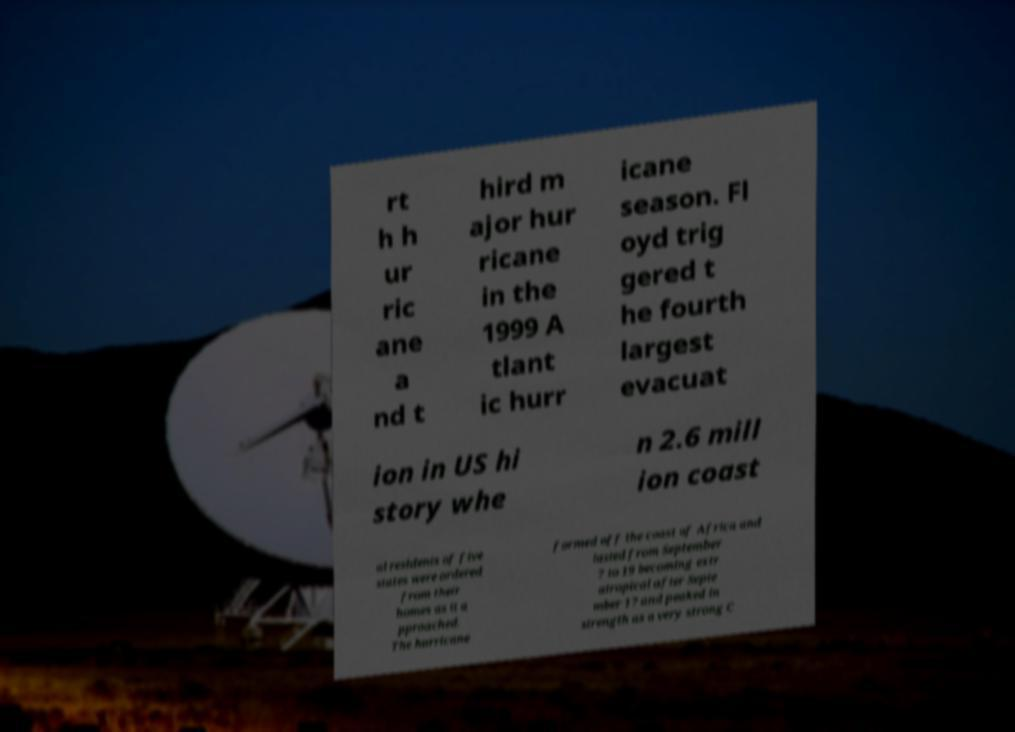There's text embedded in this image that I need extracted. Can you transcribe it verbatim? rt h h ur ric ane a nd t hird m ajor hur ricane in the 1999 A tlant ic hurr icane season. Fl oyd trig gered t he fourth largest evacuat ion in US hi story whe n 2.6 mill ion coast al residents of five states were ordered from their homes as it a pproached. The hurricane formed off the coast of Africa and lasted from September 7 to 19 becoming extr atropical after Septe mber 17 and peaked in strength as a very strong C 